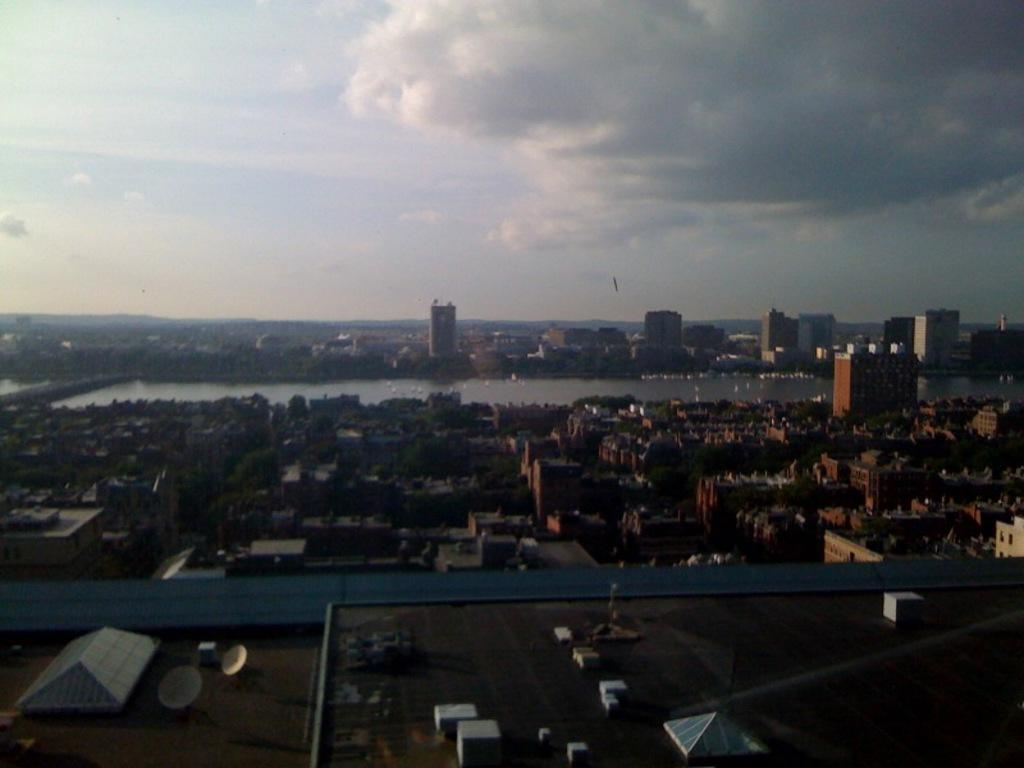What type of equipment can be seen in the image? There are satellite dishes in the image. Where are these satellite dishes located? They are on the roof top. What else can be seen on the roof top? There are objects on the roof top. What type of structures are visible in the image? There are buildings in the image. What natural elements can be seen in the image? There are trees and water visible in the image. What is visible in the background of the image? The sky is visible in the background of the image. Can you describe the sky in the image? The sky has clouds in it. What type of sugar is being used to glue the cap onto the satellite dish in the image? There is no sugar, glue, or cap present in the image. The image only shows satellite dishes, objects on the roof top, buildings, trees, water, and a sky with clouds. 